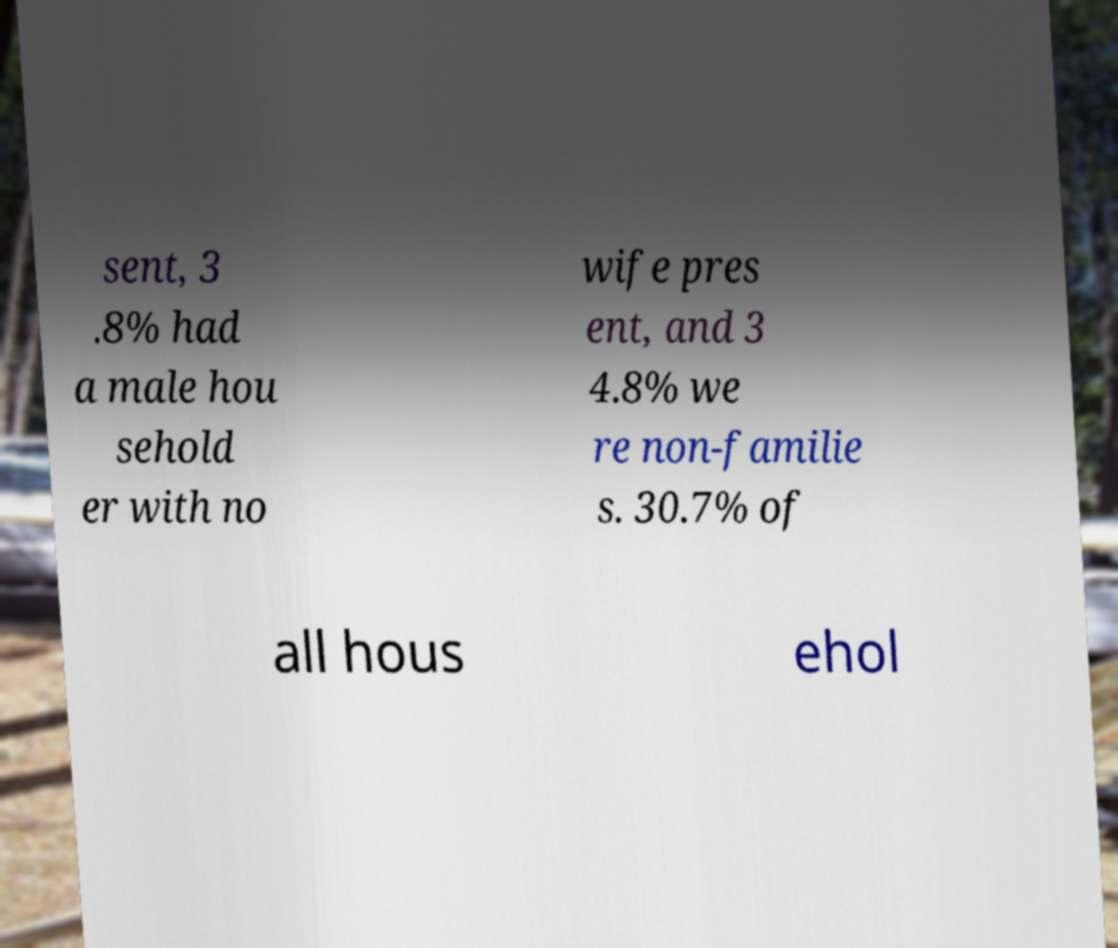Could you assist in decoding the text presented in this image and type it out clearly? sent, 3 .8% had a male hou sehold er with no wife pres ent, and 3 4.8% we re non-familie s. 30.7% of all hous ehol 